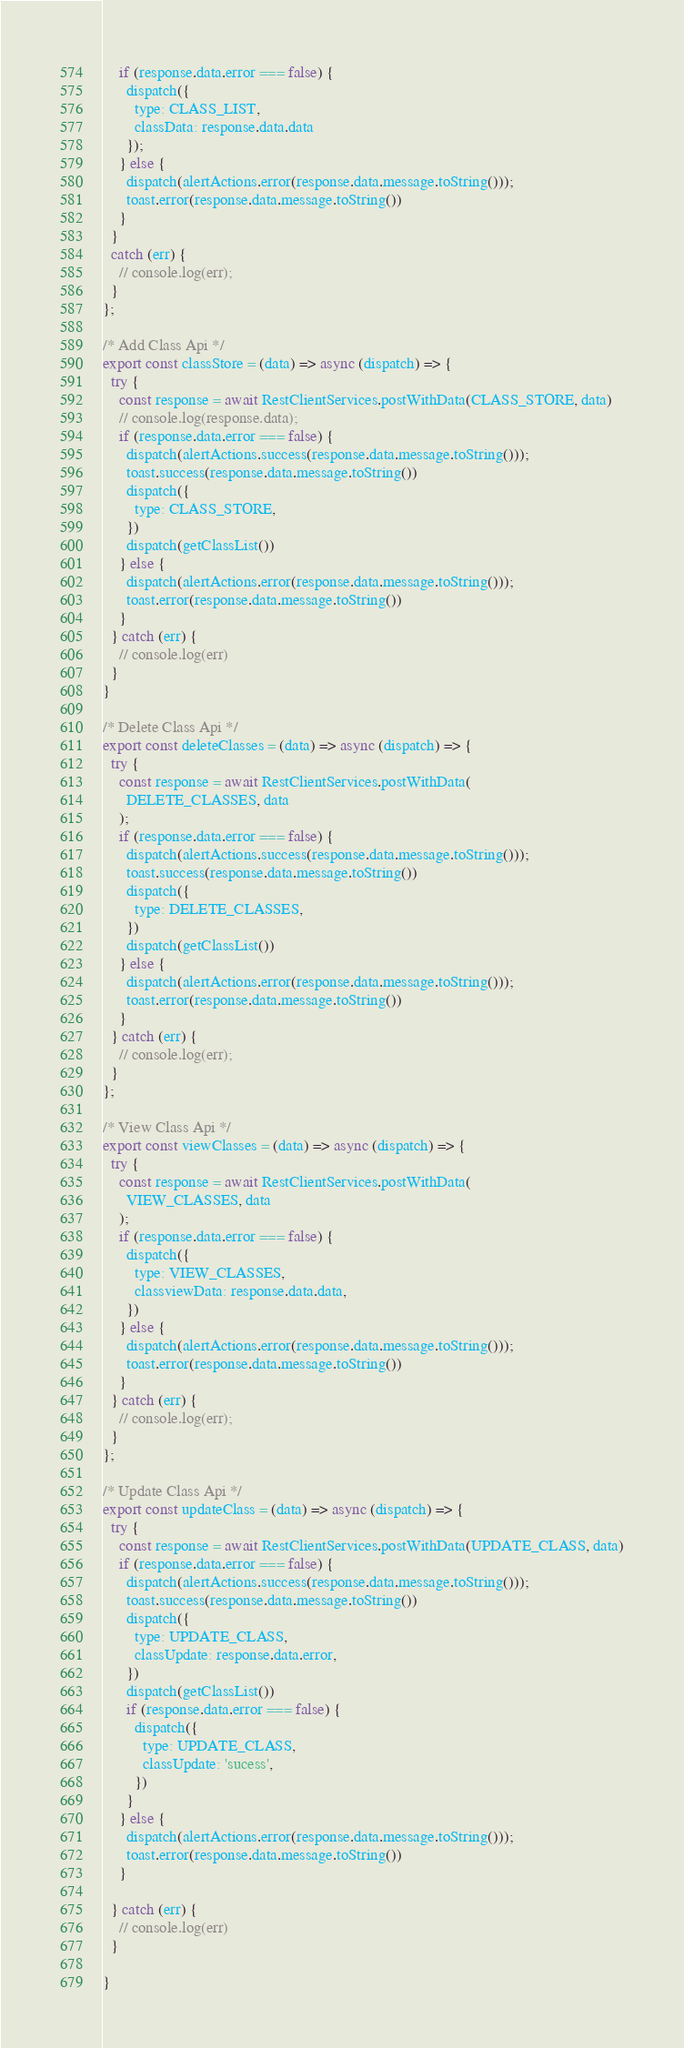<code> <loc_0><loc_0><loc_500><loc_500><_JavaScript_>    if (response.data.error === false) {
      dispatch({
        type: CLASS_LIST,
        classData: response.data.data
      });
    } else {
      dispatch(alertActions.error(response.data.message.toString()));
      toast.error(response.data.message.toString())
    }
  }
  catch (err) {
    // console.log(err);
  }
};

/* Add Class Api */
export const classStore = (data) => async (dispatch) => {
  try {
    const response = await RestClientServices.postWithData(CLASS_STORE, data)
    // console.log(response.data);
    if (response.data.error === false) {
      dispatch(alertActions.success(response.data.message.toString()));
      toast.success(response.data.message.toString())
      dispatch({
        type: CLASS_STORE,
      })
      dispatch(getClassList())
    } else {
      dispatch(alertActions.error(response.data.message.toString()));
      toast.error(response.data.message.toString())
    }
  } catch (err) {
    // console.log(err)
  }
}

/* Delete Class Api */
export const deleteClasses = (data) => async (dispatch) => {
  try {
    const response = await RestClientServices.postWithData(
      DELETE_CLASSES, data
    );
    if (response.data.error === false) {
      dispatch(alertActions.success(response.data.message.toString()));
      toast.success(response.data.message.toString())
      dispatch({
        type: DELETE_CLASSES,
      })
      dispatch(getClassList())
    } else {
      dispatch(alertActions.error(response.data.message.toString()));
      toast.error(response.data.message.toString())
    }
  } catch (err) {
    // console.log(err);
  }
};

/* View Class Api */
export const viewClasses = (data) => async (dispatch) => {
  try {
    const response = await RestClientServices.postWithData(
      VIEW_CLASSES, data
    );
    if (response.data.error === false) {
      dispatch({
        type: VIEW_CLASSES,
        classviewData: response.data.data,
      })
    } else {
      dispatch(alertActions.error(response.data.message.toString()));
      toast.error(response.data.message.toString())
    }
  } catch (err) {
    // console.log(err);
  }
};

/* Update Class Api */
export const updateClass = (data) => async (dispatch) => {
  try {
    const response = await RestClientServices.postWithData(UPDATE_CLASS, data)
    if (response.data.error === false) {
      dispatch(alertActions.success(response.data.message.toString()));
      toast.success(response.data.message.toString())
      dispatch({
        type: UPDATE_CLASS,
        classUpdate: response.data.error,
      })
      dispatch(getClassList())
      if (response.data.error === false) {
        dispatch({
          type: UPDATE_CLASS,
          classUpdate: 'sucess',
        })
      }
    } else {
      dispatch(alertActions.error(response.data.message.toString()));
      toast.error(response.data.message.toString())
    }

  } catch (err) {
    // console.log(err)
  }

}
</code> 